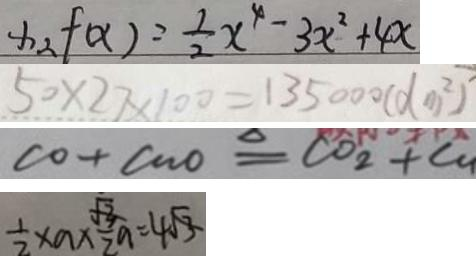Convert formula to latex. <formula><loc_0><loc_0><loc_500><loc_500>x _ { 2 } f ( x ) = \frac { 1 } { 2 } x ^ { 4 } - 3 x ^ { 2 } + 4 x 
 5 0 \times 2 7 \times 1 0 0 = 1 3 5 0 0 0 ( d m ^ { 2 } ) 
 C O + C u O \xlongequal { \Delta } C O _ { 2 } + C u 
 \frac { 1 } { 2 } \times a \times \frac { \sqrt { 3 } } { 2 } a = 4 \sqrt { 3 }</formula> 